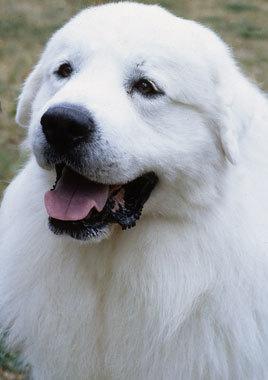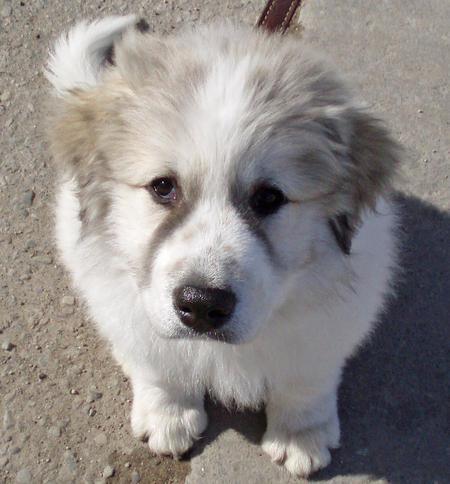The first image is the image on the left, the second image is the image on the right. Assess this claim about the two images: "The dog on the right image is of a young puppy.". Correct or not? Answer yes or no. Yes. 